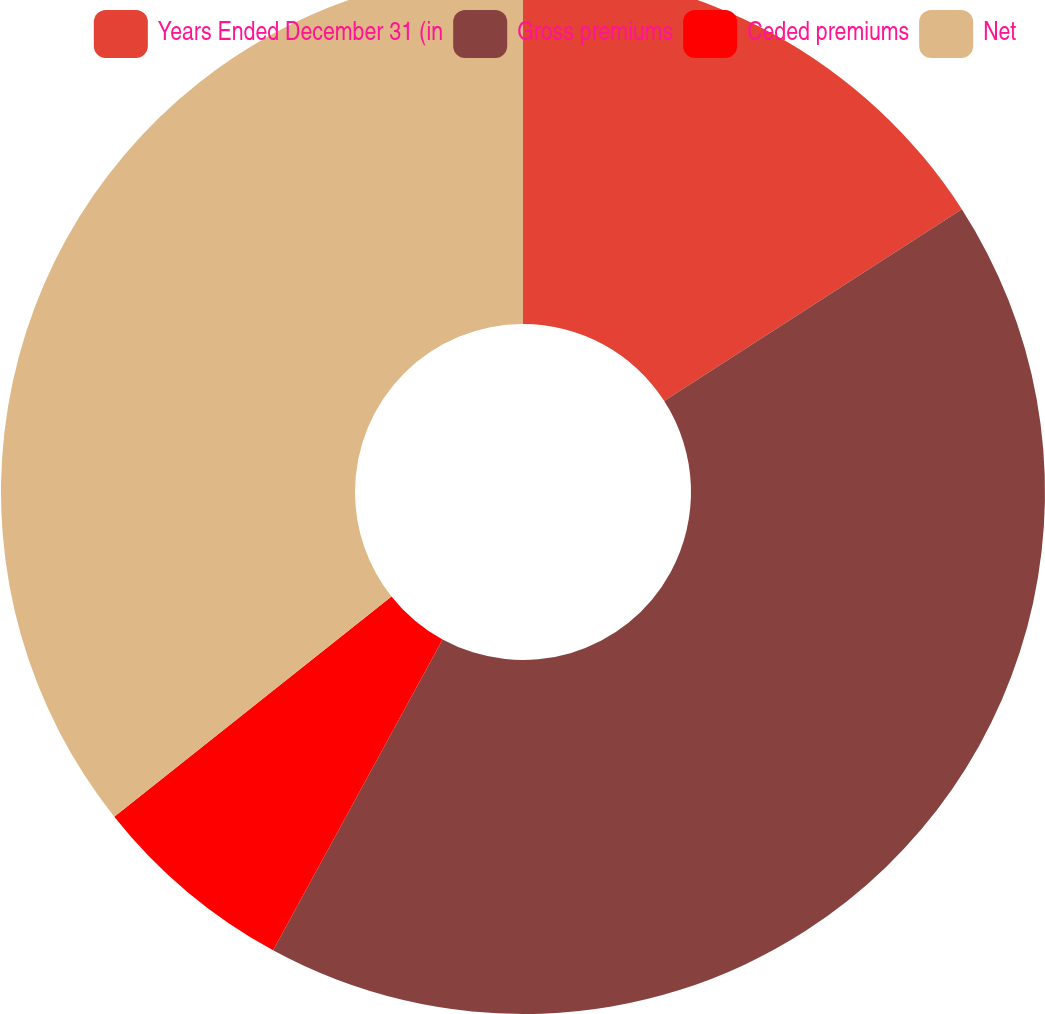<chart> <loc_0><loc_0><loc_500><loc_500><pie_chart><fcel>Years Ended December 31 (in<fcel>Gross premiums<fcel>Ceded premiums<fcel>Net<nl><fcel>15.89%<fcel>42.05%<fcel>6.37%<fcel>35.68%<nl></chart> 